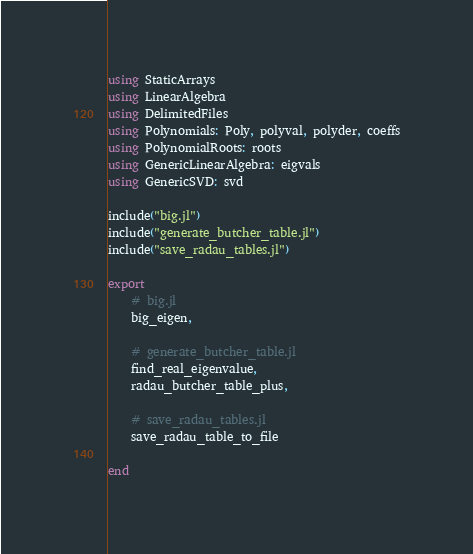<code> <loc_0><loc_0><loc_500><loc_500><_Julia_>using StaticArrays
using LinearAlgebra
using DelimitedFiles
using Polynomials: Poly, polyval, polyder, coeffs
using PolynomialRoots: roots
using GenericLinearAlgebra: eigvals
using GenericSVD: svd

include("big.jl")
include("generate_butcher_table.jl")
include("save_radau_tables.jl")

export
    # big.jl
    big_eigen,

    # generate_butcher_table.jl
    find_real_eigenvalue,
    radau_butcher_table_plus,

    # save_radau_tables.jl
    save_radau_table_to_file

end
</code> 